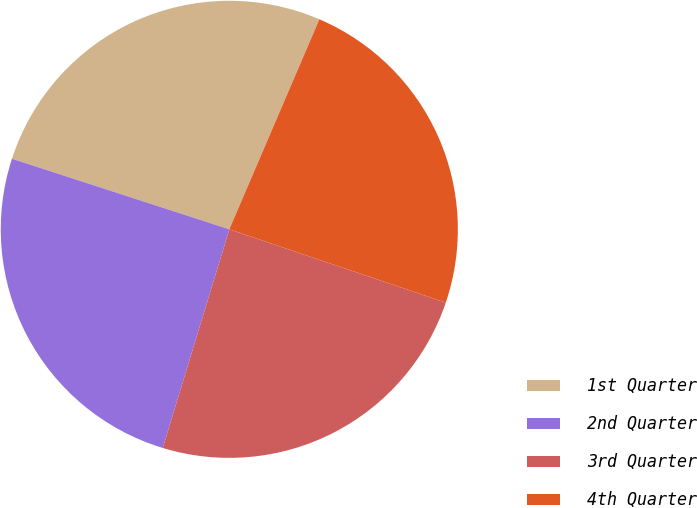Convert chart. <chart><loc_0><loc_0><loc_500><loc_500><pie_chart><fcel>1st Quarter<fcel>2nd Quarter<fcel>3rd Quarter<fcel>4th Quarter<nl><fcel>26.45%<fcel>25.29%<fcel>24.51%<fcel>23.75%<nl></chart> 